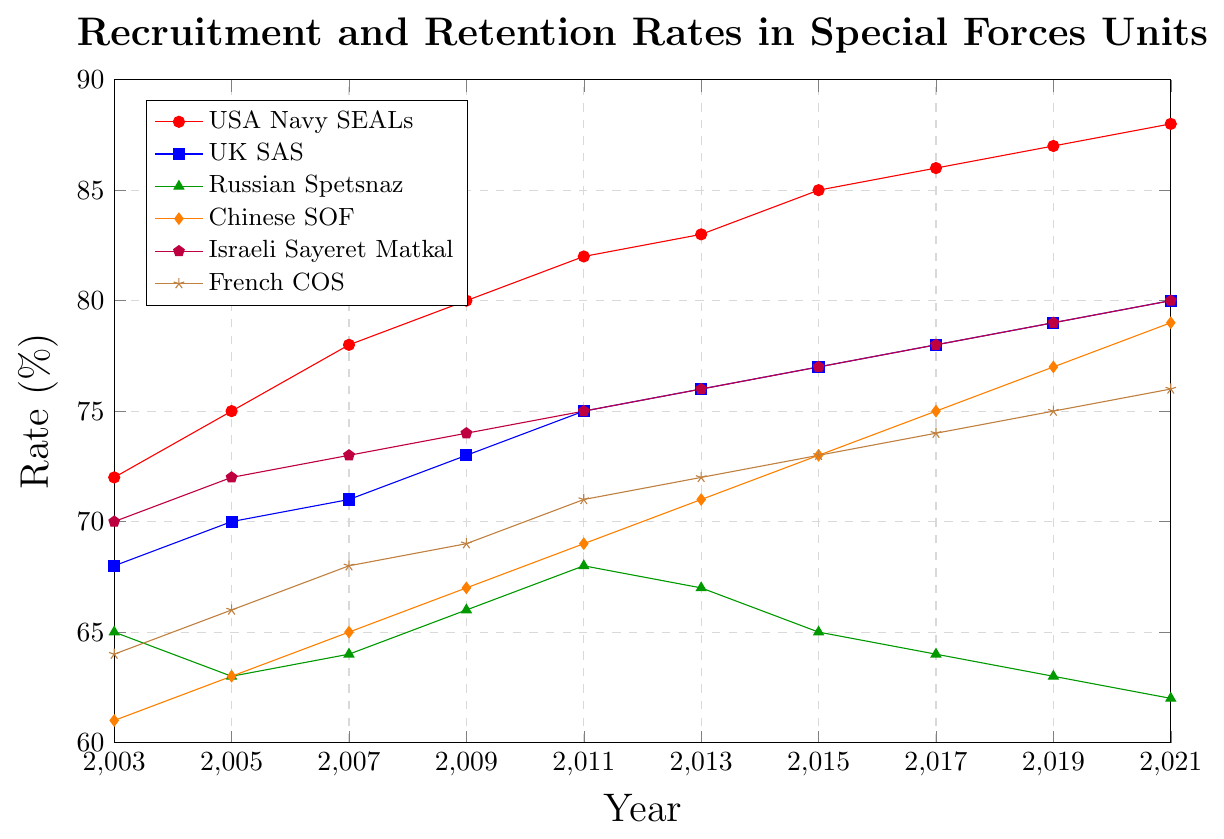What is the trend in recruitment and retention rates for the USA Navy SEALs from 2003 to 2021? Observing the plotted line representing the USA Navy SEALs, it continuously increases from 72% in 2003 to 88% in 2021.
Answer: Increasing trend Which special forces unit had a decrease in recruitment and retention rates over the two decades? By comparing the rates, only the Russian Spetsnaz shows a consistent decrease from 65% in 2003 to 62% in 2021.
Answer: Russian Spetsnaz Between 2011 and 2017, which unit had the greatest increase in recruitment and retention rates? Calculating the differences, the Chinese SOF increased from 69% to 75%, which is an increase of 6%. Other units show smaller increases within this interval.
Answer: Chinese SOF In 2021, which two special forces units have the same recruitment and retention rate? Checking the values, both UK SAS and Israeli Sayeret Matkal have a recruitment and retention rate of 80% in 2021.
Answer: UK SAS and Israeli Sayeret Matkal What was the average recruitment and retention rate of the French COS in the years 2003 and 2021? The sum of the recruitment and retention rates in 2003 and 2021 is (64 + 76) = 140. Dividing by 2 gives the average as 70%.
Answer: 70% By how much did the recruitment and retention rate for the UK SAS increase from 2003 to 2021? The rate for UK SAS increased from 68% in 2003 to 80% in 2021. The difference is 80 - 68 = 12%.
Answer: 12% Which unit had the second highest recruitment and retention rate in 2015? Checking the 2015 values, the USA Navy SEALs had the highest at 85%, and Israeli Sayeret Matkal had the second highest at 77%.
Answer: Israeli Sayeret Matkal How much greater is the recruitment and retention rate of the USA Navy SEALs compared to the Russian Spetsnaz in 2021? The difference is calculated as 88% (USA Navy SEALs) - 62% (Russian Spetsnaz) = 26%.
Answer: 26% What is the total recruitment and retention rate for all units combined in 2009? Summing up all the rates in 2009: 80 (USA Navy SEALs) + 73 (UK SAS) + 66 (Russian Spetsnaz) + 67 (Chinese SOF) + 74 (Israeli Sayeret Matkal) + 69 (French COS) = 429.
Answer: 429 Which unit's recruitment and retention rate saw the least change over the years? Observing all changes across the years, the UK SAS had the rate increase moderately from 68% in 2003 to 80% in 2021, fewer than other significant rises or drops seen in other units.
Answer: UK SAS 